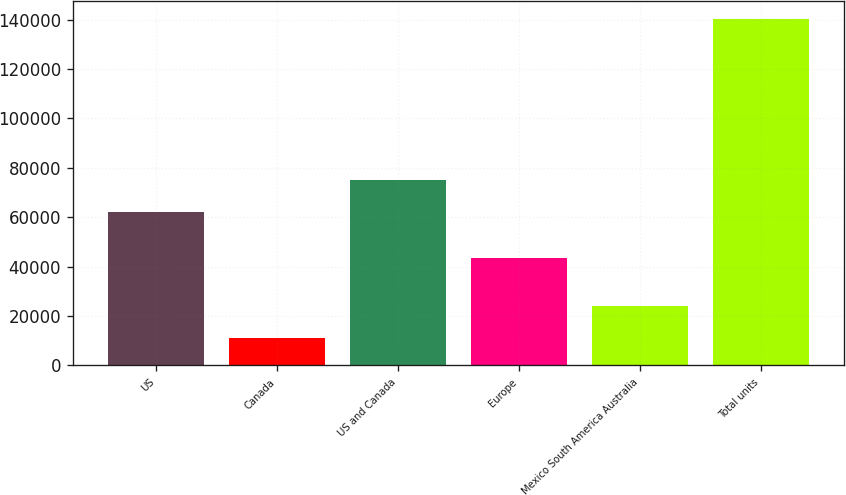Convert chart. <chart><loc_0><loc_0><loc_500><loc_500><bar_chart><fcel>US<fcel>Canada<fcel>US and Canada<fcel>Europe<fcel>Mexico South America Australia<fcel>Total units<nl><fcel>62200<fcel>10900<fcel>75150<fcel>43500<fcel>23850<fcel>140400<nl></chart> 